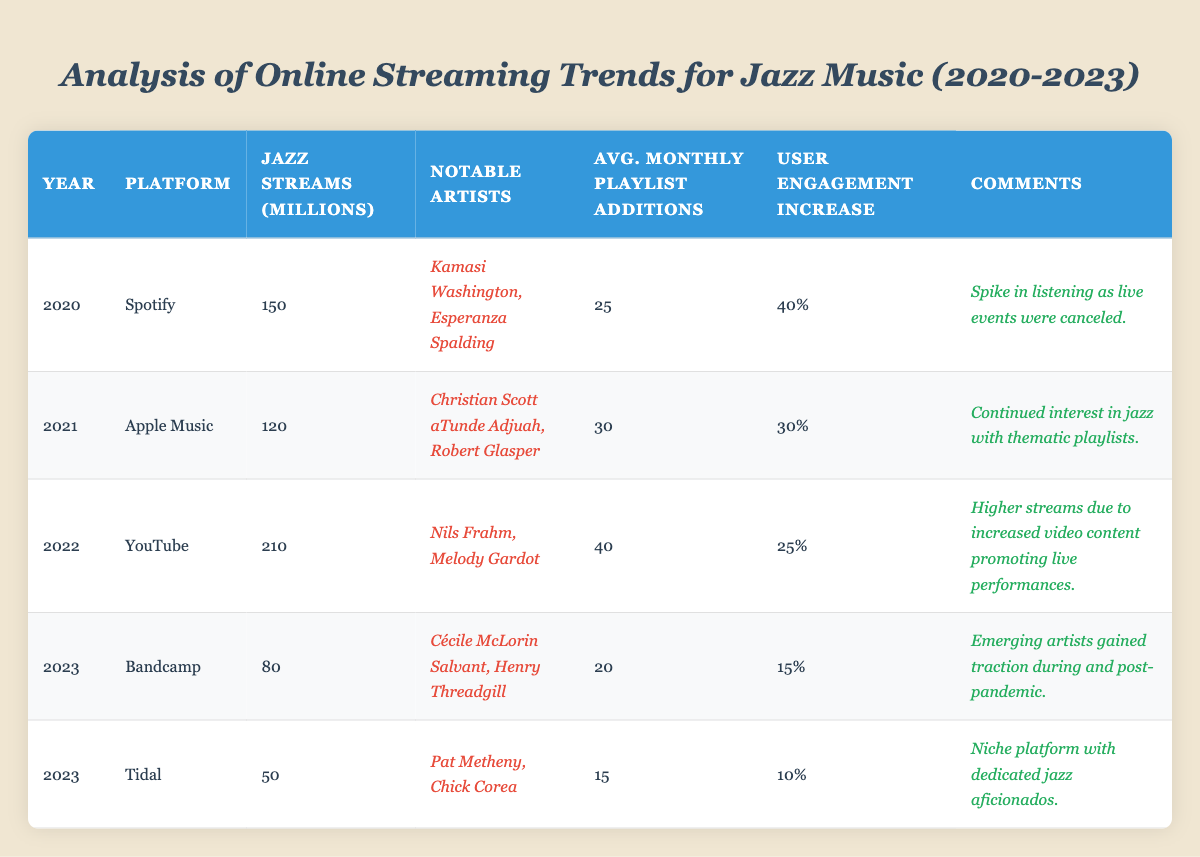What platform had the highest jazz genre streams in millions in 2022? The table shows that YouTube had 210 million jazz genre streams in 2022, which is the highest compared to other platforms in that year.
Answer: YouTube Which year saw a decrease in user engagement increase percentage compared to the previous year? Looking at the user engagement increase percentages: 2020 (40%), 2021 (30%), 2022 (25%), and 2023 (15%). The percentage decreased from 40% in 2020 to 30% in 2021.
Answer: 2021 What was the average number of monthly playlist additions for jazz music in 2023 across both Bandcamp and Tidal? For 2023, Bandcamp had 20 average playlist additions per month and Tidal had 15. Adding these gives 35, and dividing by 2 gives an average of 17.5.
Answer: 17.5 Did the notable artists on Apple Music in 2021 include Esperanza Spalding? The notable artists listed for Apple Music in 2021 are Christian Scott aTunde Adjuah and Robert Glasper; Esperanza Spalding is not mentioned.
Answer: No What trend can be inferred from the increase in jazz genre streams on YouTube in 2022 compared to the previous years? Comparing 2022 with 2020 and 2021, YouTube's streams rose to 210 million in 2022, while earlier years showed only 150 million in 2020 and 120 million in 2021, indicating a significant growth influenced by increased video content.
Answer: Significant growth Which platform had the least average monthly playlist additions in 2023? Bandcamp had 20 and Tidal had 15 for average monthly playlist additions in 2023, making Tidal the platform with the least additions.
Answer: Tidal What was the change in jazz genre streams from 2021 to 2022? In 2021, the streams were 120 million and in 2022 they were 210 million. The change is 210 - 120 = 90 million, indicating an increase in streams.
Answer: Increased by 90 million Was there a noticeable spike in user engagement increase percentage during the year 2020? Yes, the percentage for 2020 was 40%, which is higher than 30% in 2021. This indicates a spike in engagement.
Answer: Yes How many notable artists were mentioned for the platform Spotify in 2020? The table indicates two notable artists, Kamasi Washington and Esperanza Spalding, for Spotify in 2020.
Answer: 2 What was the total number of jazz genre streams across all platforms in 2023? For 2023, Bandcamp has 80 million and Tidal has 50 million. Adding these gives a total of 130 million for 2023.
Answer: 130 million Which year had the lowest jazz streams in millions, and what was the figure? 2023 had the lowest jazz streams with 50 million on Tidal, compared to other years listed.
Answer: 50 million 